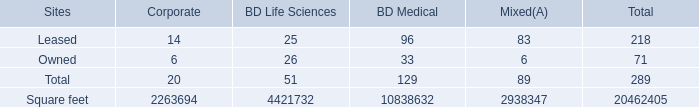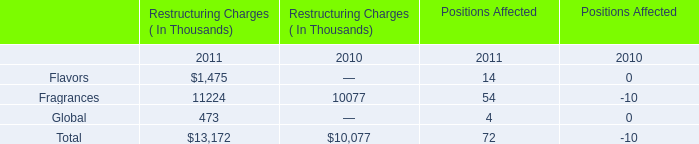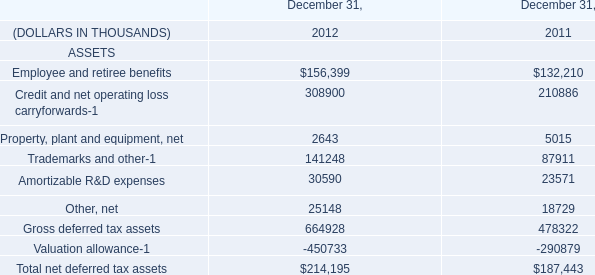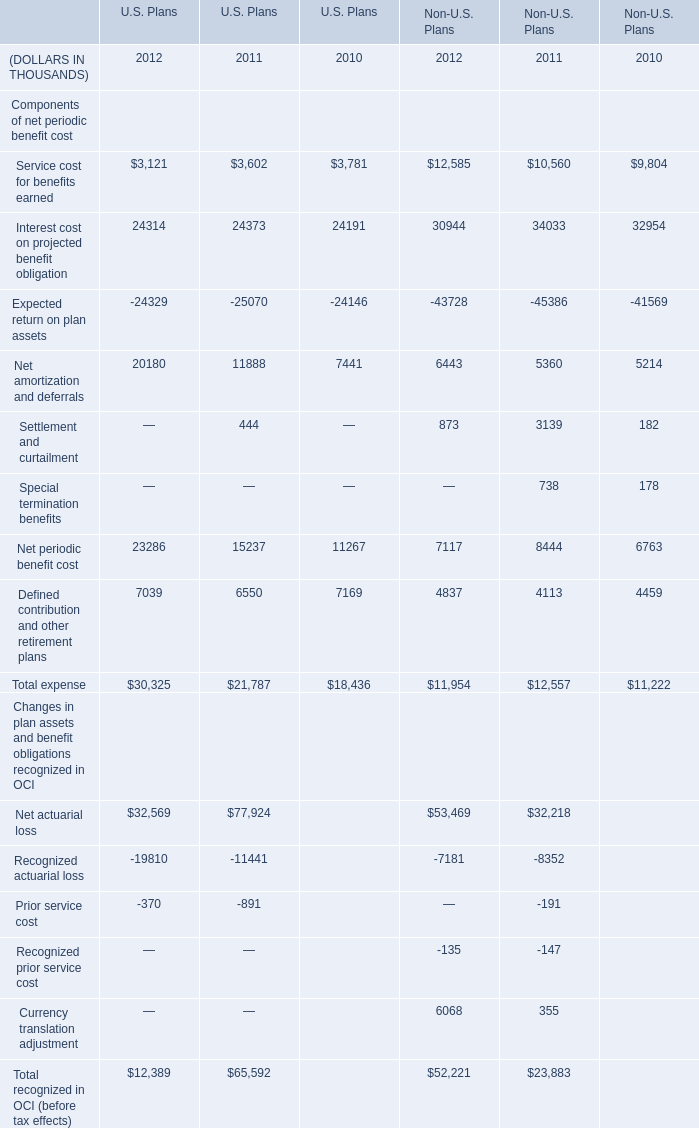what percentage of mixed use units are owned? 
Computations: (6 / 89)
Answer: 0.06742. 